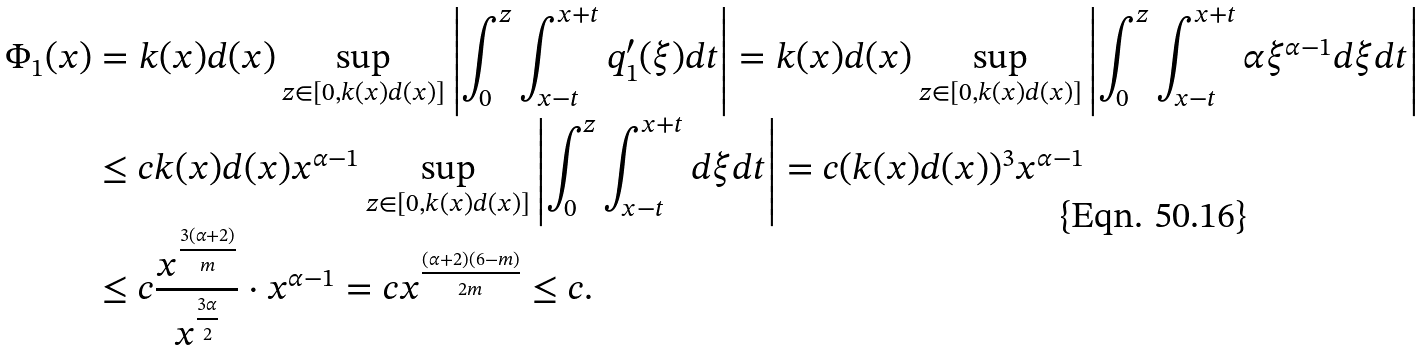Convert formula to latex. <formula><loc_0><loc_0><loc_500><loc_500>\Phi _ { 1 } ( x ) & = k ( x ) d ( x ) \sup _ { z \in [ 0 , k ( x ) d ( x ) ] } \left | \int _ { 0 } ^ { z } \int _ { x - t } ^ { x + t } q _ { 1 } ^ { \prime } ( \xi ) d t \right | = k ( x ) d ( x ) \sup _ { z \in [ 0 , k ( x ) d ( x ) ] } \left | \int _ { 0 } ^ { z } \int _ { x - t } ^ { x + t } \alpha \xi ^ { \alpha - 1 } d \xi d t \right | \\ & \leq c k ( x ) d ( x ) x ^ { \alpha - 1 } \sup _ { z \in [ 0 , k ( x ) d ( x ) ] } \left | \int _ { 0 } ^ { z } \int _ { x - t } ^ { x + t } d \xi d t \right | = c ( k ( x ) d ( x ) ) ^ { 3 } x ^ { \alpha - 1 } \\ & \leq c \frac { x ^ { \frac { 3 ( \alpha + 2 ) } { m } } } { x ^ { \frac { 3 \alpha } { 2 } } } \cdot x ^ { \alpha - 1 } = c x ^ { \frac { ( \alpha + 2 ) ( 6 - m ) } { 2 m } } \leq c .</formula> 